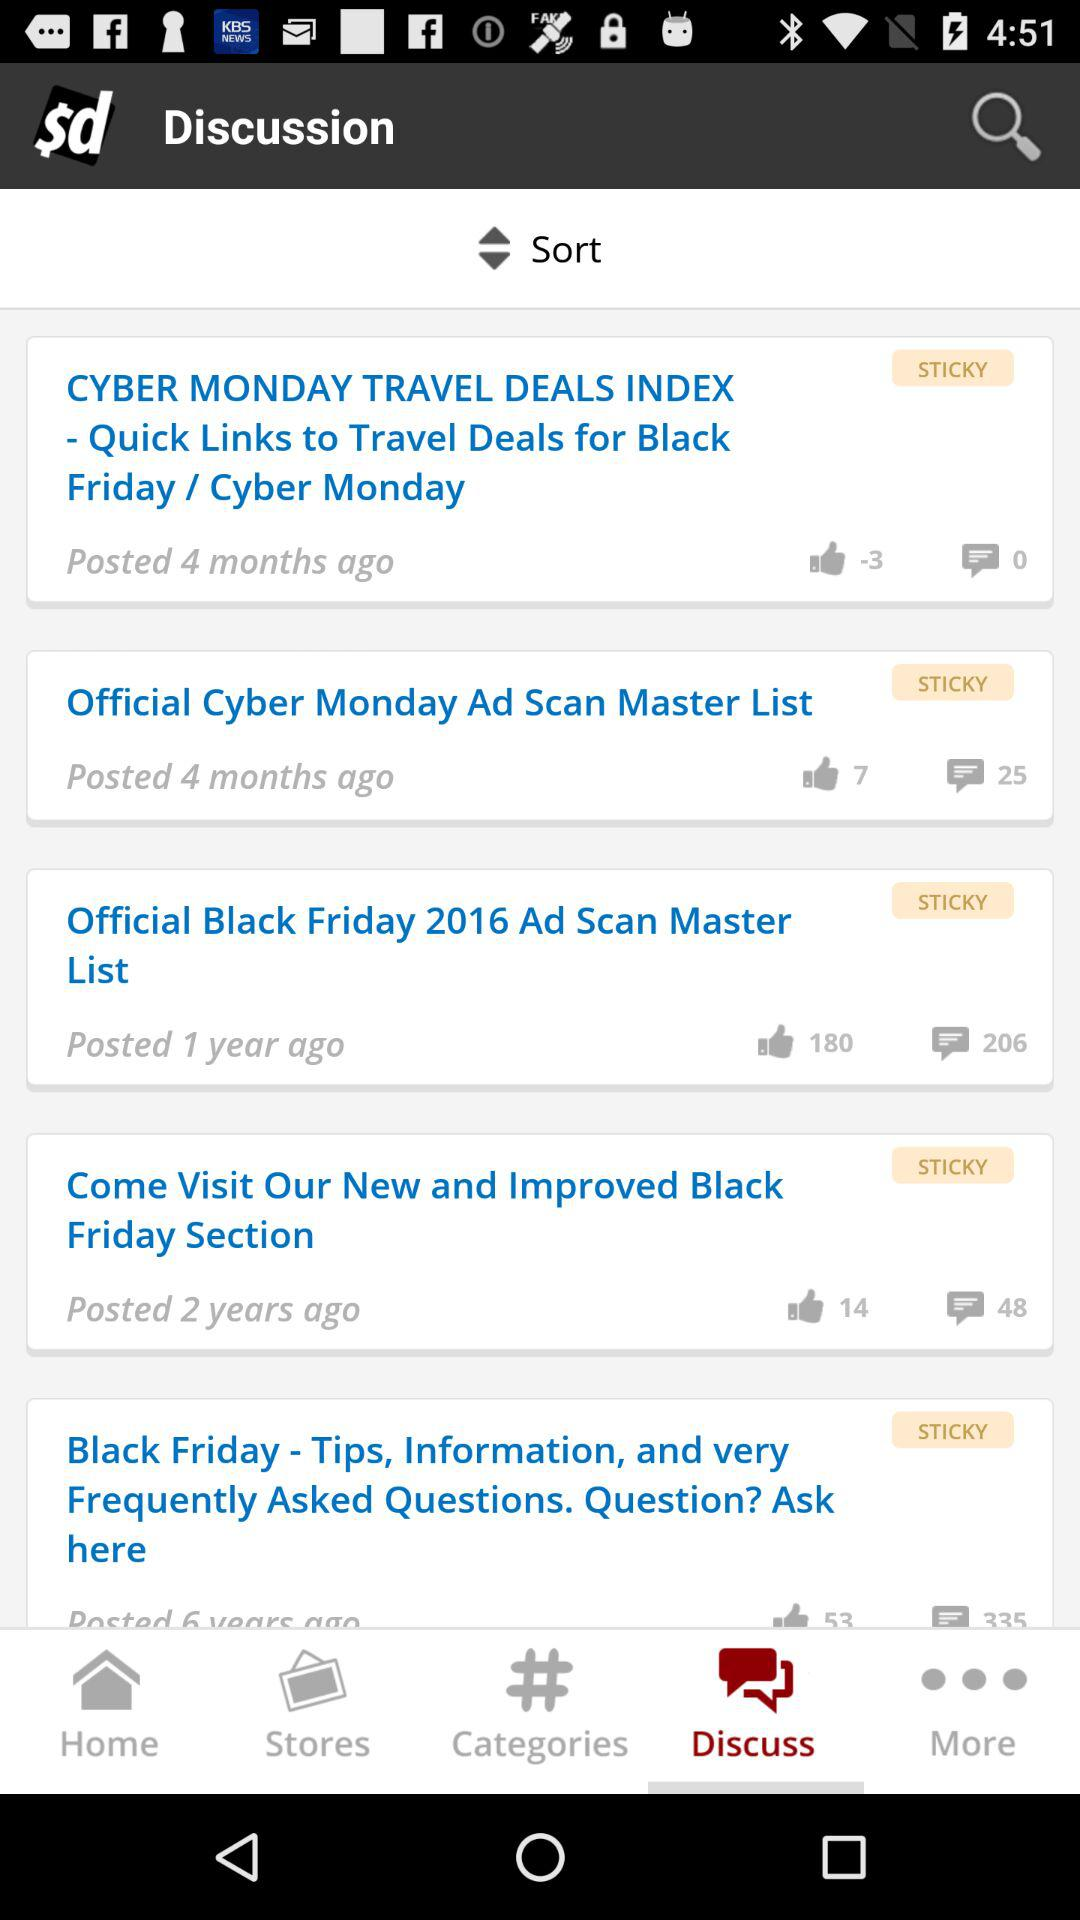Which tab is selected? The selected tab is "Discuss". 